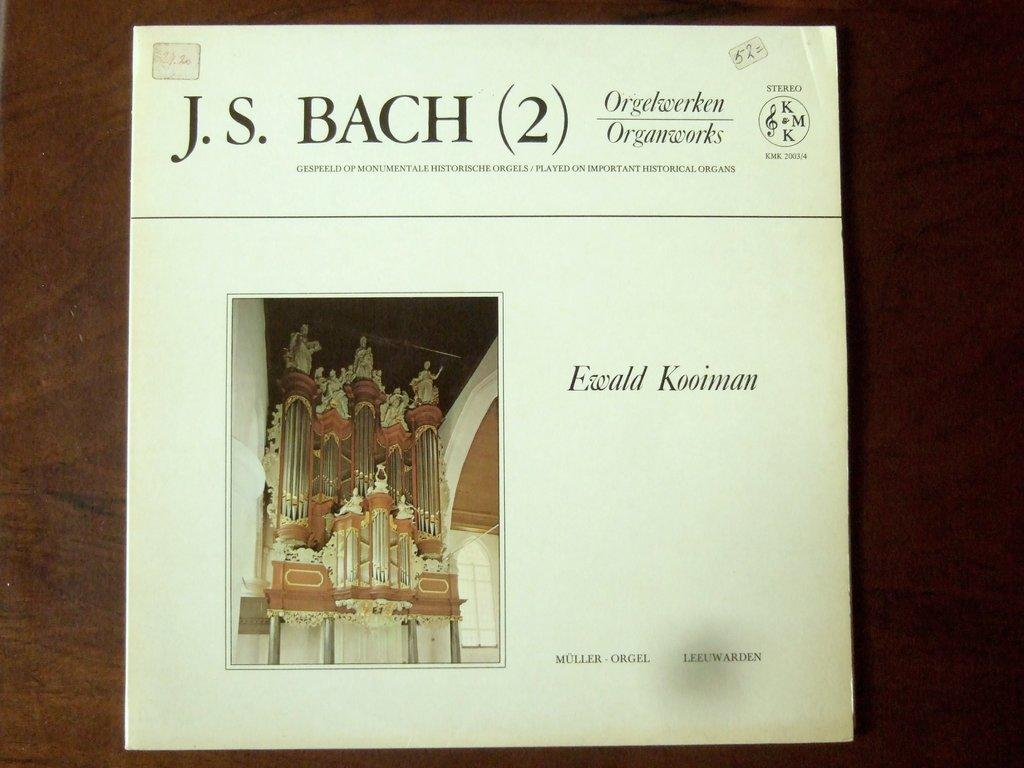Provide a one-sentence caption for the provided image. A program shows a piece of music written by composer J.S. Bach. 